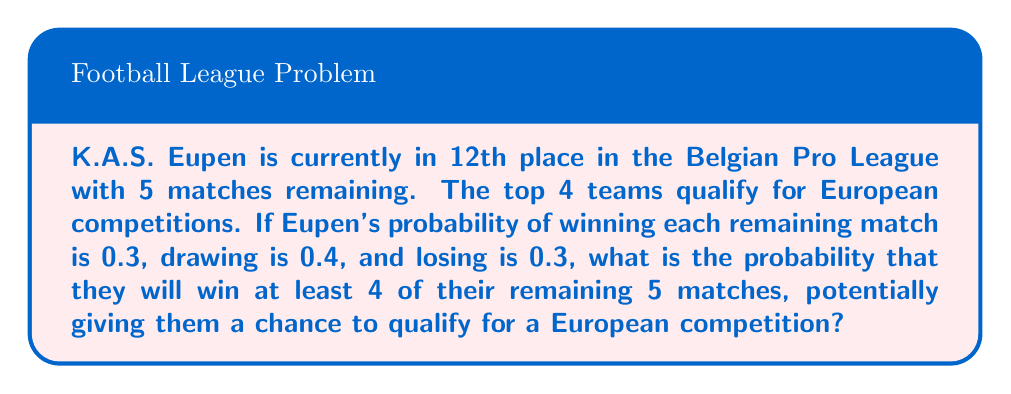Can you answer this question? Let's approach this step-by-step using the binomial probability distribution:

1) We can model this scenario as a binomial distribution with:
   $n = 5$ (number of matches)
   $p = 0.3$ (probability of winning a single match)
   $k \geq 4$ (we want at least 4 wins)

2) The probability of exactly $k$ successes in $n$ trials is given by:

   $$P(X = k) = \binom{n}{k} p^k (1-p)^{n-k}$$

3) We need to calculate $P(X = 4)$ and $P(X = 5)$, then sum them:

   $$P(X \geq 4) = P(X = 4) + P(X = 5)$$

4) For $k = 4$:
   $$P(X = 4) = \binom{5}{4} (0.3)^4 (0.7)^1 = 5 \cdot 0.0081 \cdot 0.7 = 0.02835$$

5) For $k = 5$:
   $$P(X = 5) = \binom{5}{5} (0.3)^5 (0.7)^0 = 1 \cdot 0.00243 \cdot 1 = 0.00243$$

6) Sum these probabilities:
   $$P(X \geq 4) = 0.02835 + 0.00243 = 0.03078$$

Therefore, the probability of K.A.S. Eupen winning at least 4 of their remaining 5 matches is approximately 0.03078 or 3.078%.
Answer: $0.03078$ or $3.078\%$ 